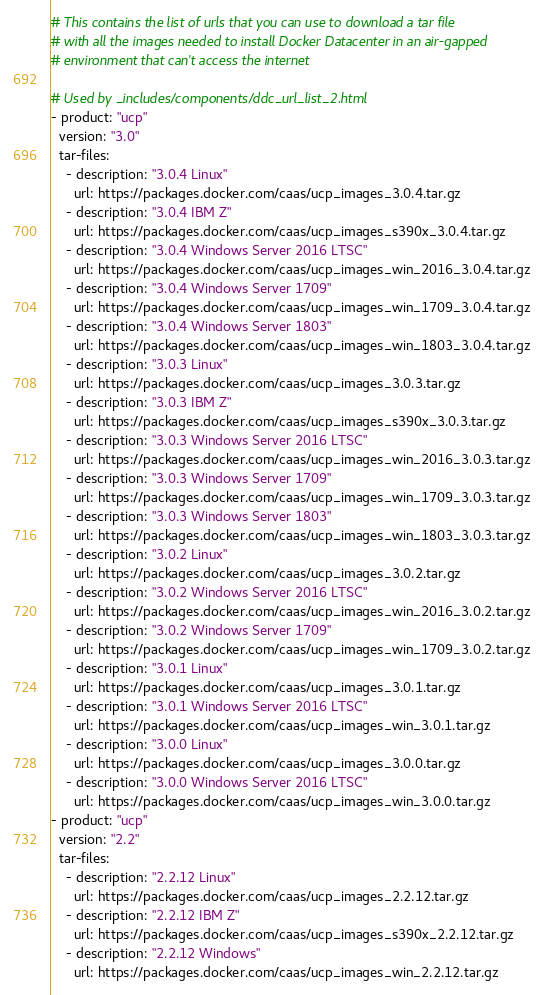<code> <loc_0><loc_0><loc_500><loc_500><_YAML_># This contains the list of urls that you can use to download a tar file
# with all the images needed to install Docker Datacenter in an air-gapped
# environment that can't access the internet

# Used by _includes/components/ddc_url_list_2.html
- product: "ucp"
  version: "3.0"
  tar-files:
    - description: "3.0.4 Linux"
      url: https://packages.docker.com/caas/ucp_images_3.0.4.tar.gz
    - description: "3.0.4 IBM Z"
      url: https://packages.docker.com/caas/ucp_images_s390x_3.0.4.tar.gz
    - description: "3.0.4 Windows Server 2016 LTSC"
      url: https://packages.docker.com/caas/ucp_images_win_2016_3.0.4.tar.gz
    - description: "3.0.4 Windows Server 1709"
      url: https://packages.docker.com/caas/ucp_images_win_1709_3.0.4.tar.gz
    - description: "3.0.4 Windows Server 1803"
      url: https://packages.docker.com/caas/ucp_images_win_1803_3.0.4.tar.gz
    - description: "3.0.3 Linux"
      url: https://packages.docker.com/caas/ucp_images_3.0.3.tar.gz
    - description: "3.0.3 IBM Z"
      url: https://packages.docker.com/caas/ucp_images_s390x_3.0.3.tar.gz
    - description: "3.0.3 Windows Server 2016 LTSC"
      url: https://packages.docker.com/caas/ucp_images_win_2016_3.0.3.tar.gz
    - description: "3.0.3 Windows Server 1709"
      url: https://packages.docker.com/caas/ucp_images_win_1709_3.0.3.tar.gz
    - description: "3.0.3 Windows Server 1803"
      url: https://packages.docker.com/caas/ucp_images_win_1803_3.0.3.tar.gz
    - description: "3.0.2 Linux"
      url: https://packages.docker.com/caas/ucp_images_3.0.2.tar.gz
    - description: "3.0.2 Windows Server 2016 LTSC"
      url: https://packages.docker.com/caas/ucp_images_win_2016_3.0.2.tar.gz
    - description: "3.0.2 Windows Server 1709"
      url: https://packages.docker.com/caas/ucp_images_win_1709_3.0.2.tar.gz
    - description: "3.0.1 Linux"
      url: https://packages.docker.com/caas/ucp_images_3.0.1.tar.gz
    - description: "3.0.1 Windows Server 2016 LTSC"
      url: https://packages.docker.com/caas/ucp_images_win_3.0.1.tar.gz
    - description: "3.0.0 Linux"
      url: https://packages.docker.com/caas/ucp_images_3.0.0.tar.gz
    - description: "3.0.0 Windows Server 2016 LTSC"
      url: https://packages.docker.com/caas/ucp_images_win_3.0.0.tar.gz
- product: "ucp"
  version: "2.2"
  tar-files:
    - description: "2.2.12 Linux"
      url: https://packages.docker.com/caas/ucp_images_2.2.12.tar.gz
    - description: "2.2.12 IBM Z"
      url: https://packages.docker.com/caas/ucp_images_s390x_2.2.12.tar.gz
    - description: "2.2.12 Windows"
      url: https://packages.docker.com/caas/ucp_images_win_2.2.12.tar.gz  </code> 